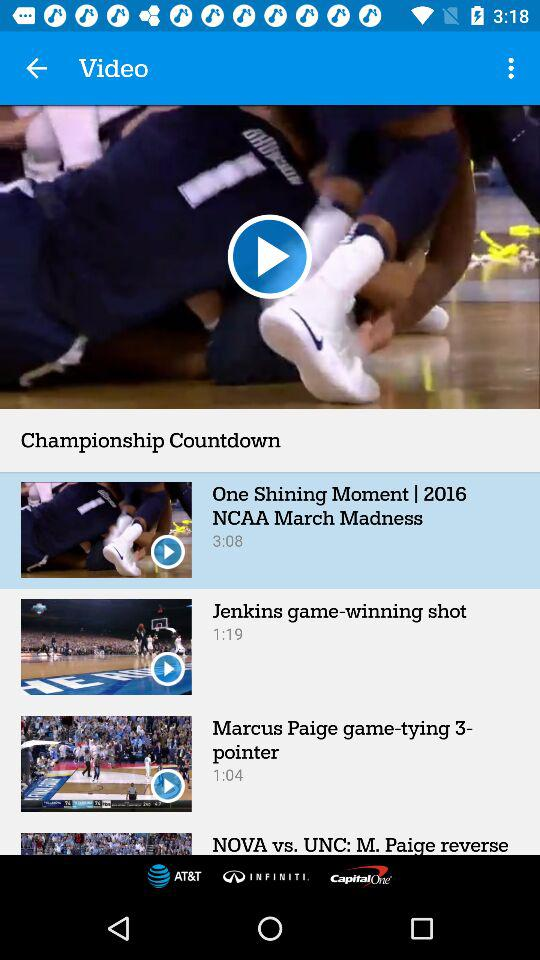What is the duration of "Marcus Paige game-tying 3-pointer"? The duration is 1:04. 